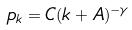<formula> <loc_0><loc_0><loc_500><loc_500>p _ { k } = C ( k + A ) ^ { - \gamma }</formula> 